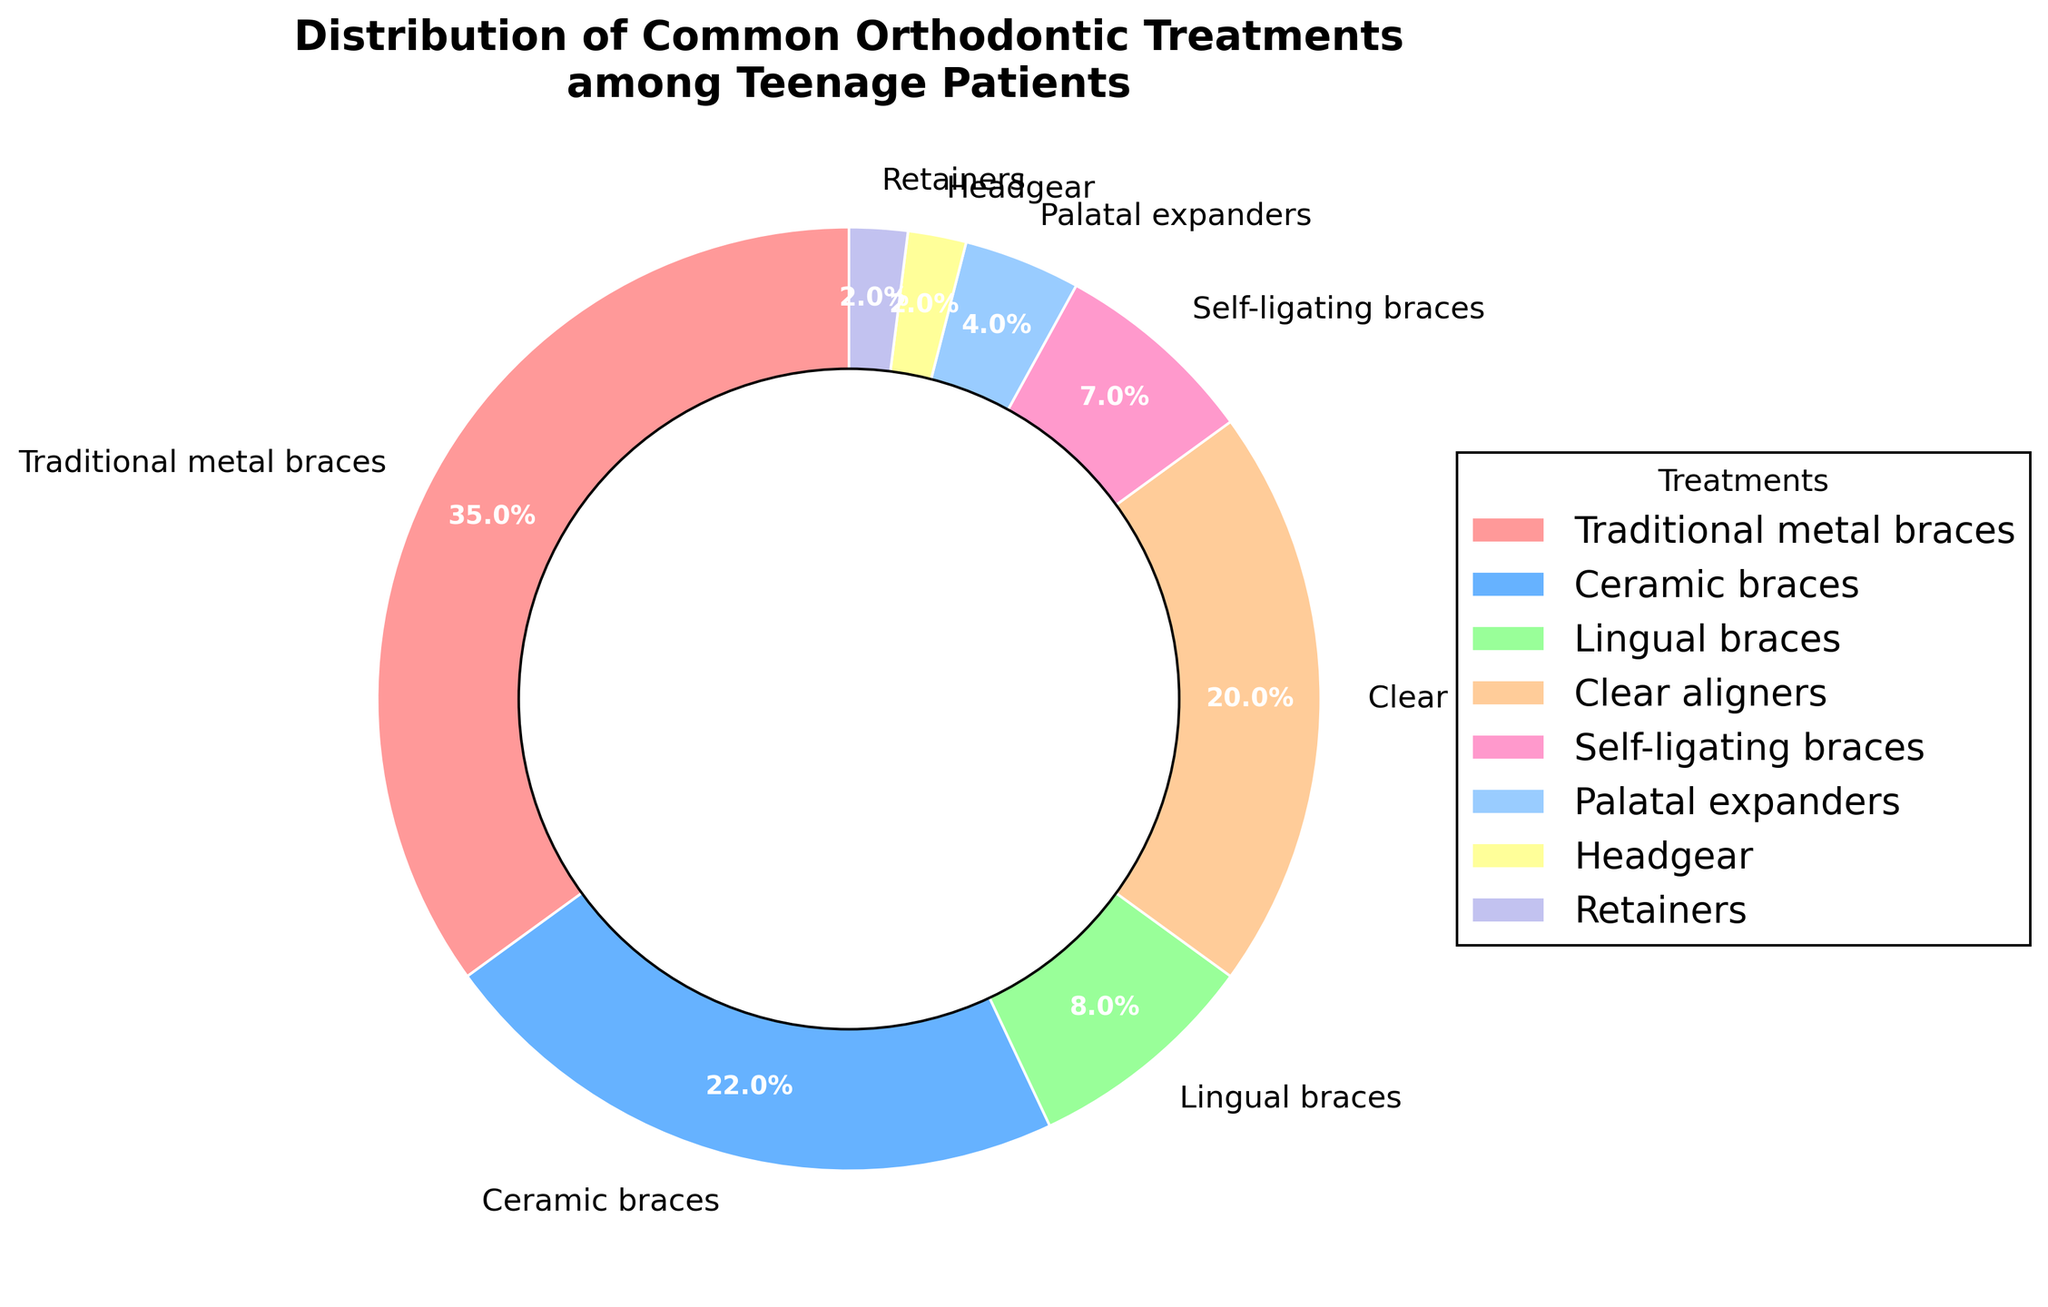What's the most common orthodontic treatment among teenage patients? The pie chart shows the percentage distribution of various orthodontic treatments. By looking at the largest slice in the chart, Traditional metal braces have the biggest portion with 35%.
Answer: Traditional metal braces Which treatment is preferred less than lingual braces but more than headgear? Lingual braces are 8%, and headgear is 2%. The treatment preferred less than lingual braces and more than headgear is within this range. Retainers fit this criterion with 2%.
Answer: Retainers What percentage of patients use either ceramic braces or clear aligners? From the chart, ceramic braces account for 22% and clear aligners for 20%. Adding these percentages together, 22% + 20% results in 42%.
Answer: 42% What is the total percentage of treatments involving braces (Traditional metal braces, Ceramic braces, Lingual braces, Self-ligating braces)? Summing the percentages of all treatments that involve braces: Traditional metal braces (35%), Ceramic braces (22%), Lingual braces (8%), and Self-ligating braces (7%). Adding these: 35% + 22% + 8% + 7% = 72%.
Answer: 72% Which treatment has the smallest percentage, and what percentage is it? The pie chart shows the smallest slice representing Headgear with 2%.
Answer: Headgear, 2% What is the difference in percentage between the most and least common treatments? The most common treatment is Traditional metal braces with 35%, and the least common is Headgear and Retainers, each with 2%. The difference is 35% - 2% = 33%.
Answer: 33% Are clear aligners more preferred than lingual braces? If so, by how much? Clear aligners represent 20%, and lingual braces represent 8%. Comparing these, clear aligners are more preferred. The difference is 20% - 8% = 12%.
Answer: Yes, by 12% What is the combined percentage of the three least common treatments? The three least common treatments are Headgear (2%), Retainers (2%), and Palatal expanders (4%). Adding these: 2% + 2% + 4% = 8%.
Answer: 8% Which treatment has the second highest percentage? The chart shows the second largest slice representing Ceramic braces with 22%.
Answer: Ceramic braces How much more common are traditional metal braces compared to self-ligating braces? Traditional metal braces account for 35% and self-ligating braces for 7%. The difference is 35% - 7% = 28%.
Answer: 28% 